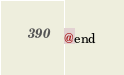Convert code to text. <code><loc_0><loc_0><loc_500><loc_500><_C_>@end

</code> 